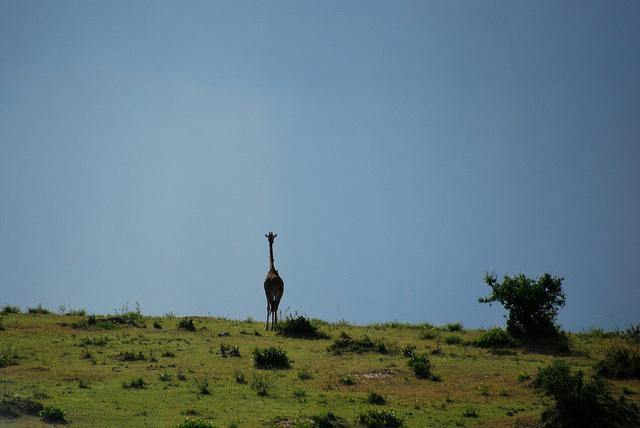How's the weather?
Keep it brief. Clear. Is it sunny out?
Quick response, please. Yes. Is this blurry?
Concise answer only. No. How many animals are facing the camera?
Write a very short answer. 1. Is there debris?
Give a very brief answer. No. Is this picture taken near water?
Write a very short answer. No. Which animals are these?
Write a very short answer. Giraffe. Is the giraffe facing the camera?
Write a very short answer. No. What color is it?
Answer briefly. Blue. Is that a boat?
Answer briefly. No. What color is the sky?
Concise answer only. Blue. Where was the picture taken of the giraffes?
Answer briefly. Africa. Does this look like a sunny day?
Answer briefly. Yes. What animal is in this scene?
Write a very short answer. Giraffe. How many animals are in the picture?
Give a very brief answer. 1. Is more sand than grass visible?
Keep it brief. No. Is the sky gray?
Short answer required. No. Does the weather look rainy?
Quick response, please. No. Is this dark bird standing on one foot?
Answer briefly. No. 